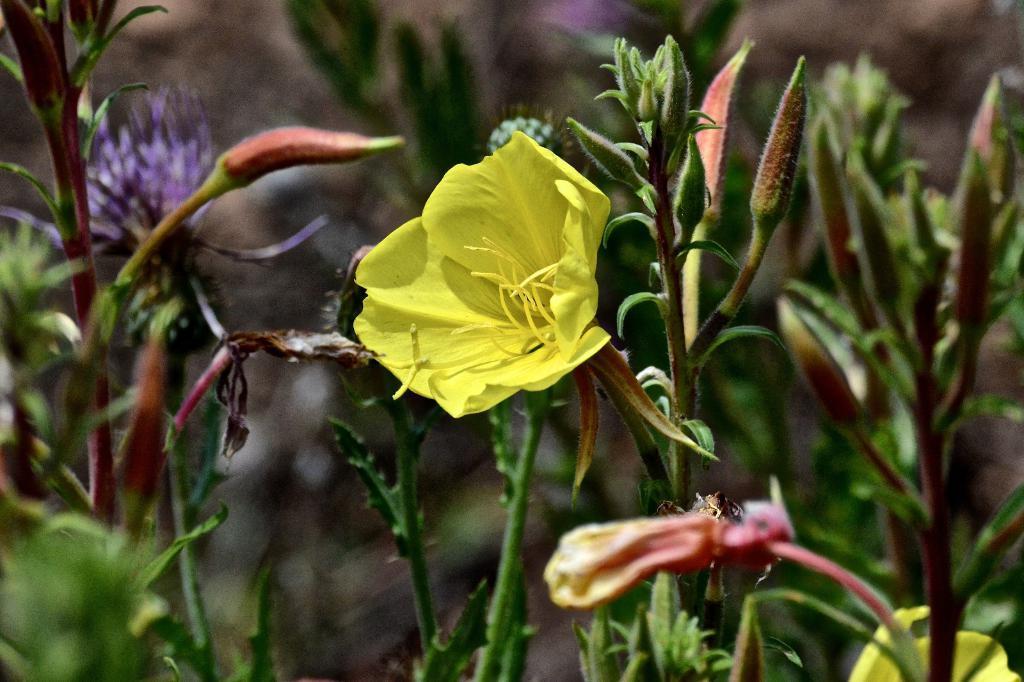Describe this image in one or two sentences. In this image we can see there are plants and flowers. 